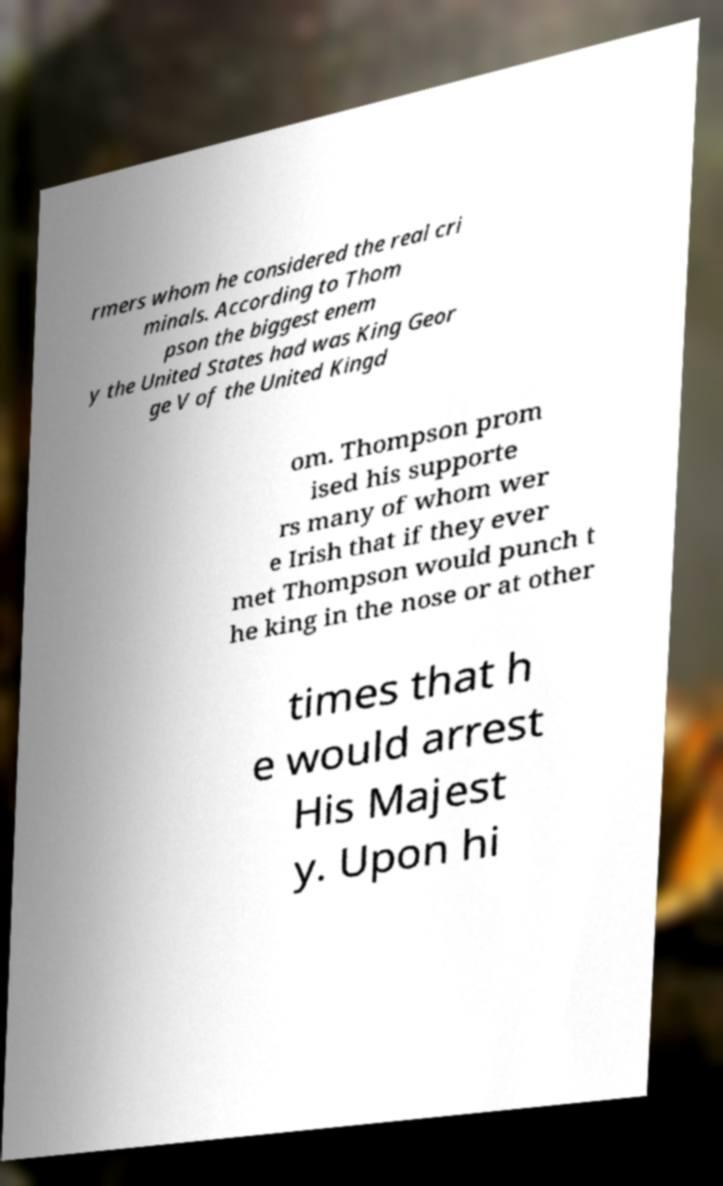Could you assist in decoding the text presented in this image and type it out clearly? rmers whom he considered the real cri minals. According to Thom pson the biggest enem y the United States had was King Geor ge V of the United Kingd om. Thompson prom ised his supporte rs many of whom wer e Irish that if they ever met Thompson would punch t he king in the nose or at other times that h e would arrest His Majest y. Upon hi 